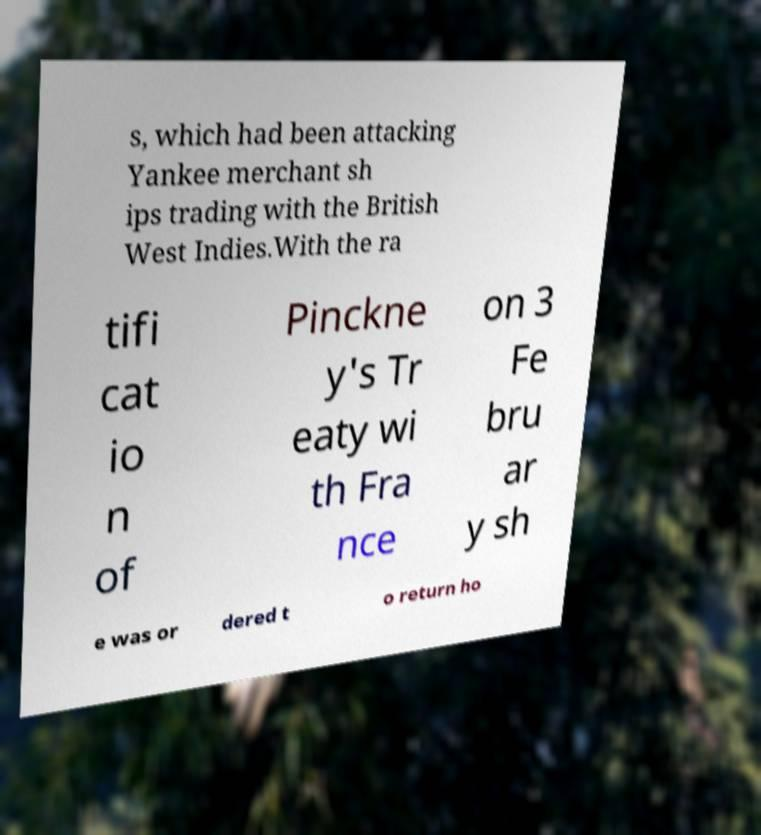Please identify and transcribe the text found in this image. s, which had been attacking Yankee merchant sh ips trading with the British West Indies.With the ra tifi cat io n of Pinckne y's Tr eaty wi th Fra nce on 3 Fe bru ar y sh e was or dered t o return ho 